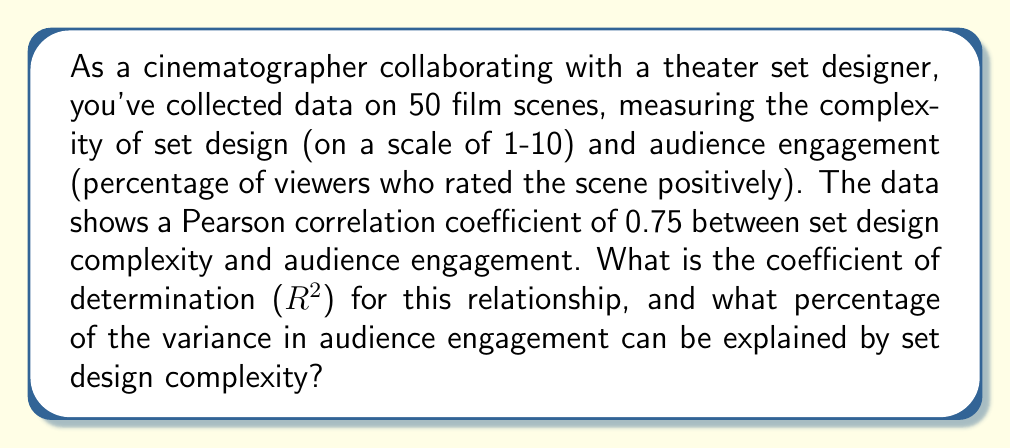Could you help me with this problem? To solve this problem, we'll follow these steps:

1. Recall that the coefficient of determination ($R^2$) is the square of the Pearson correlation coefficient ($r$).

2. Given information:
   Pearson correlation coefficient ($r$) = 0.75

3. Calculate $R^2$:
   $$R^2 = r^2 = (0.75)^2 = 0.5625$$

4. Convert $R^2$ to a percentage:
   $$0.5625 \times 100\% = 56.25\%$$

5. Interpret the result:
   The coefficient of determination ($R^2$) is 0.5625, which means that 56.25% of the variance in audience engagement can be explained by the complexity of the set design.
Answer: $R^2 = 0.5625$; 56.25% of variance explained 